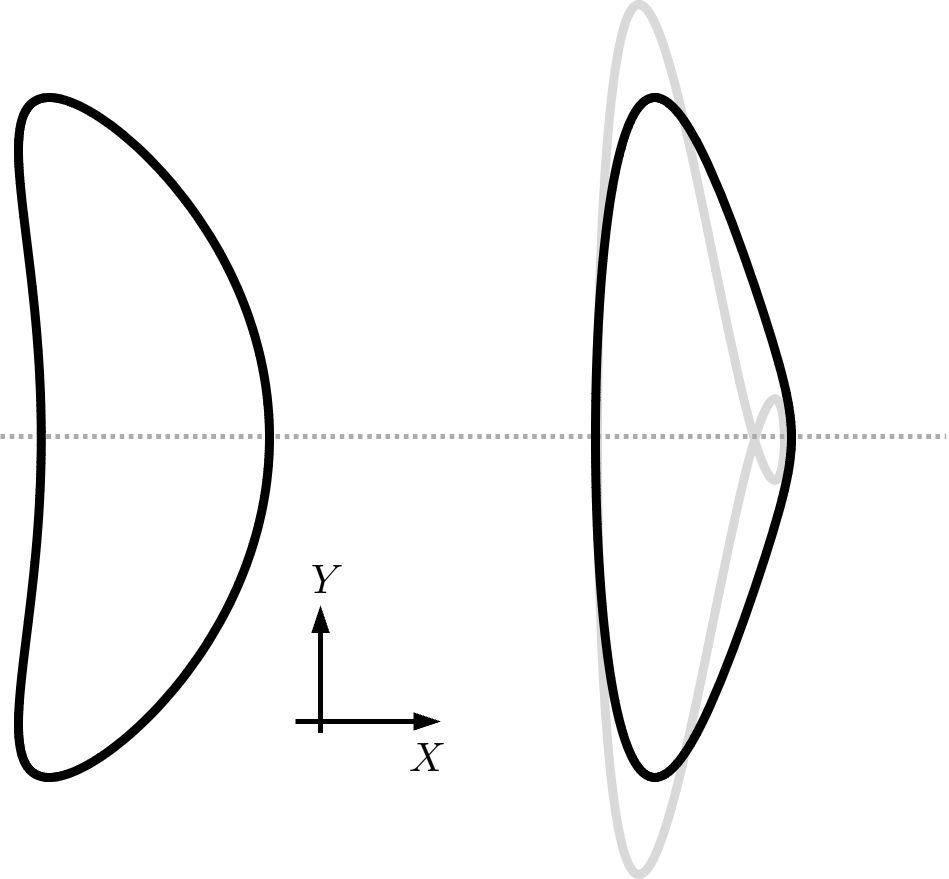Could you explain if the area of the shape changes after the transformation, and why? In the transformation shown, which appears to be a dilation, the area of the shape does change. This is because dilation adjusts the size of the shape either by enlarging or reducing it, leading to a corresponding increase or decrease in the area, depending on the scale factor applied. 